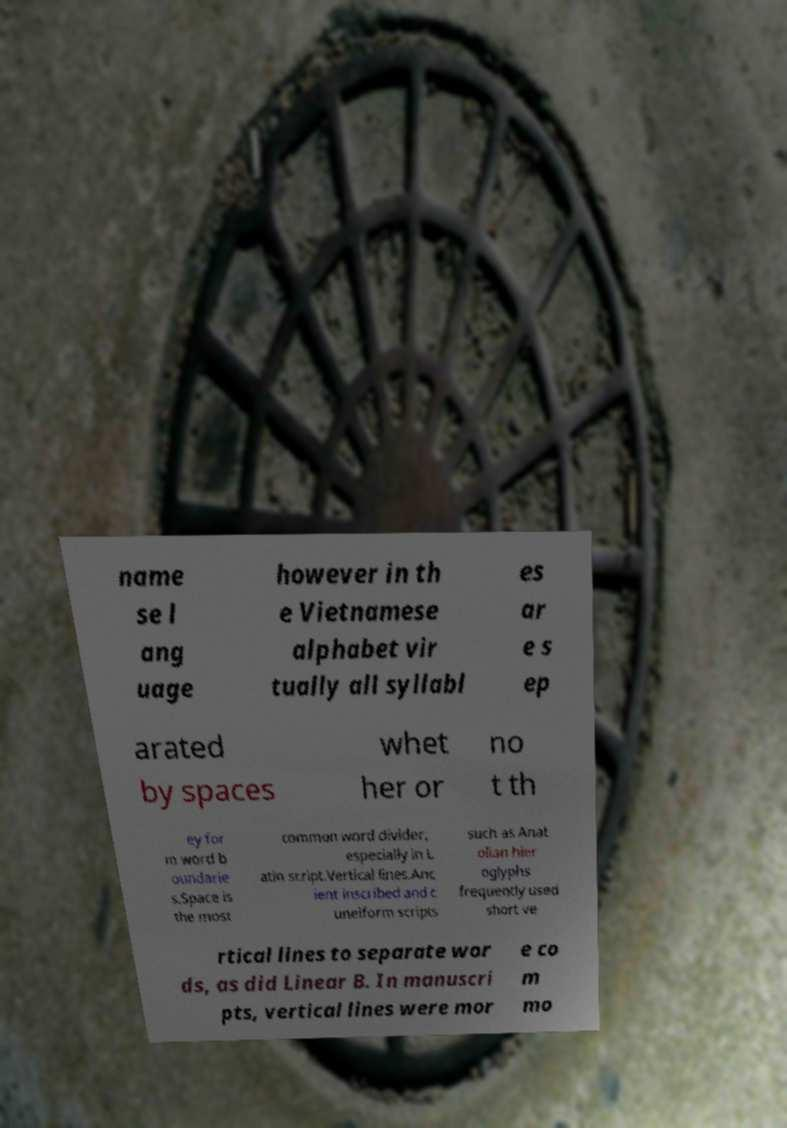Could you extract and type out the text from this image? name se l ang uage however in th e Vietnamese alphabet vir tually all syllabl es ar e s ep arated by spaces whet her or no t th ey for m word b oundarie s.Space is the most common word divider, especially in L atin script.Vertical lines.Anc ient inscribed and c uneiform scripts such as Anat olian hier oglyphs frequently used short ve rtical lines to separate wor ds, as did Linear B. In manuscri pts, vertical lines were mor e co m mo 